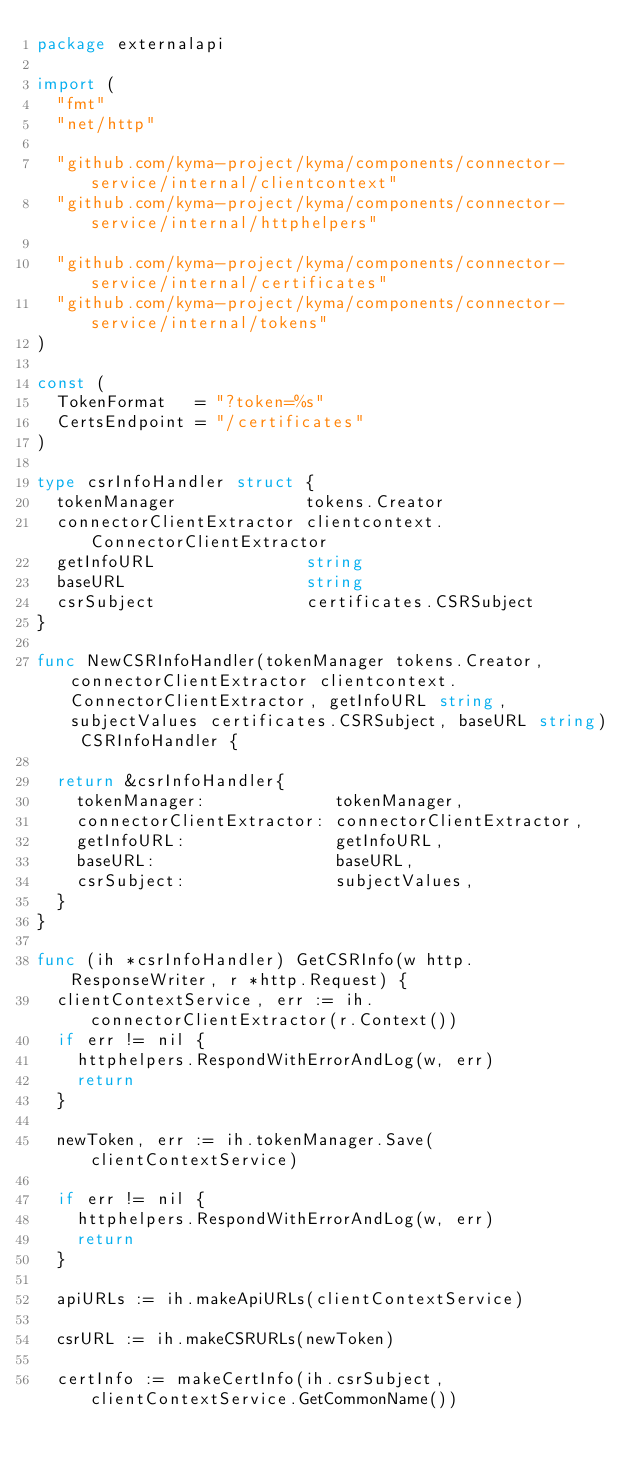<code> <loc_0><loc_0><loc_500><loc_500><_Go_>package externalapi

import (
	"fmt"
	"net/http"

	"github.com/kyma-project/kyma/components/connector-service/internal/clientcontext"
	"github.com/kyma-project/kyma/components/connector-service/internal/httphelpers"

	"github.com/kyma-project/kyma/components/connector-service/internal/certificates"
	"github.com/kyma-project/kyma/components/connector-service/internal/tokens"
)

const (
	TokenFormat   = "?token=%s"
	CertsEndpoint = "/certificates"
)

type csrInfoHandler struct {
	tokenManager             tokens.Creator
	connectorClientExtractor clientcontext.ConnectorClientExtractor
	getInfoURL               string
	baseURL                  string
	csrSubject               certificates.CSRSubject
}

func NewCSRInfoHandler(tokenManager tokens.Creator, connectorClientExtractor clientcontext.ConnectorClientExtractor, getInfoURL string, subjectValues certificates.CSRSubject, baseURL string) CSRInfoHandler {

	return &csrInfoHandler{
		tokenManager:             tokenManager,
		connectorClientExtractor: connectorClientExtractor,
		getInfoURL:               getInfoURL,
		baseURL:                  baseURL,
		csrSubject:               subjectValues,
	}
}

func (ih *csrInfoHandler) GetCSRInfo(w http.ResponseWriter, r *http.Request) {
	clientContextService, err := ih.connectorClientExtractor(r.Context())
	if err != nil {
		httphelpers.RespondWithErrorAndLog(w, err)
		return
	}

	newToken, err := ih.tokenManager.Save(clientContextService)

	if err != nil {
		httphelpers.RespondWithErrorAndLog(w, err)
		return
	}

	apiURLs := ih.makeApiURLs(clientContextService)

	csrURL := ih.makeCSRURLs(newToken)

	certInfo := makeCertInfo(ih.csrSubject, clientContextService.GetCommonName())
</code> 